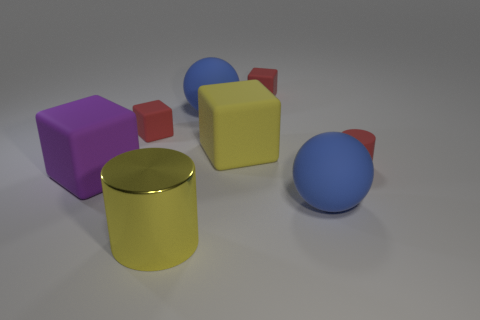How many other things are there of the same shape as the yellow matte thing?
Your response must be concise. 3. There is a big yellow rubber block that is on the right side of the cylinder that is on the left side of the tiny cylinder; what number of big rubber cubes are in front of it?
Your answer should be compact. 1. What is the color of the tiny matte block that is on the left side of the large metal thing?
Your answer should be compact. Red. There is a sphere that is to the right of the yellow matte cube; does it have the same color as the big cylinder?
Keep it short and to the point. No. There is a purple thing that is the same shape as the yellow rubber thing; what size is it?
Offer a very short reply. Large. Is there any other thing that has the same size as the yellow metallic object?
Offer a very short reply. Yes. What is the ball that is in front of the purple rubber block that is in front of the large yellow object that is behind the big yellow metal object made of?
Your answer should be very brief. Rubber. Is the number of large purple blocks to the right of the small matte cylinder greater than the number of yellow matte blocks that are left of the big yellow cylinder?
Give a very brief answer. No. Do the purple object and the yellow block have the same size?
Provide a short and direct response. Yes. There is another big object that is the same shape as the big yellow matte object; what is its color?
Provide a short and direct response. Purple. 